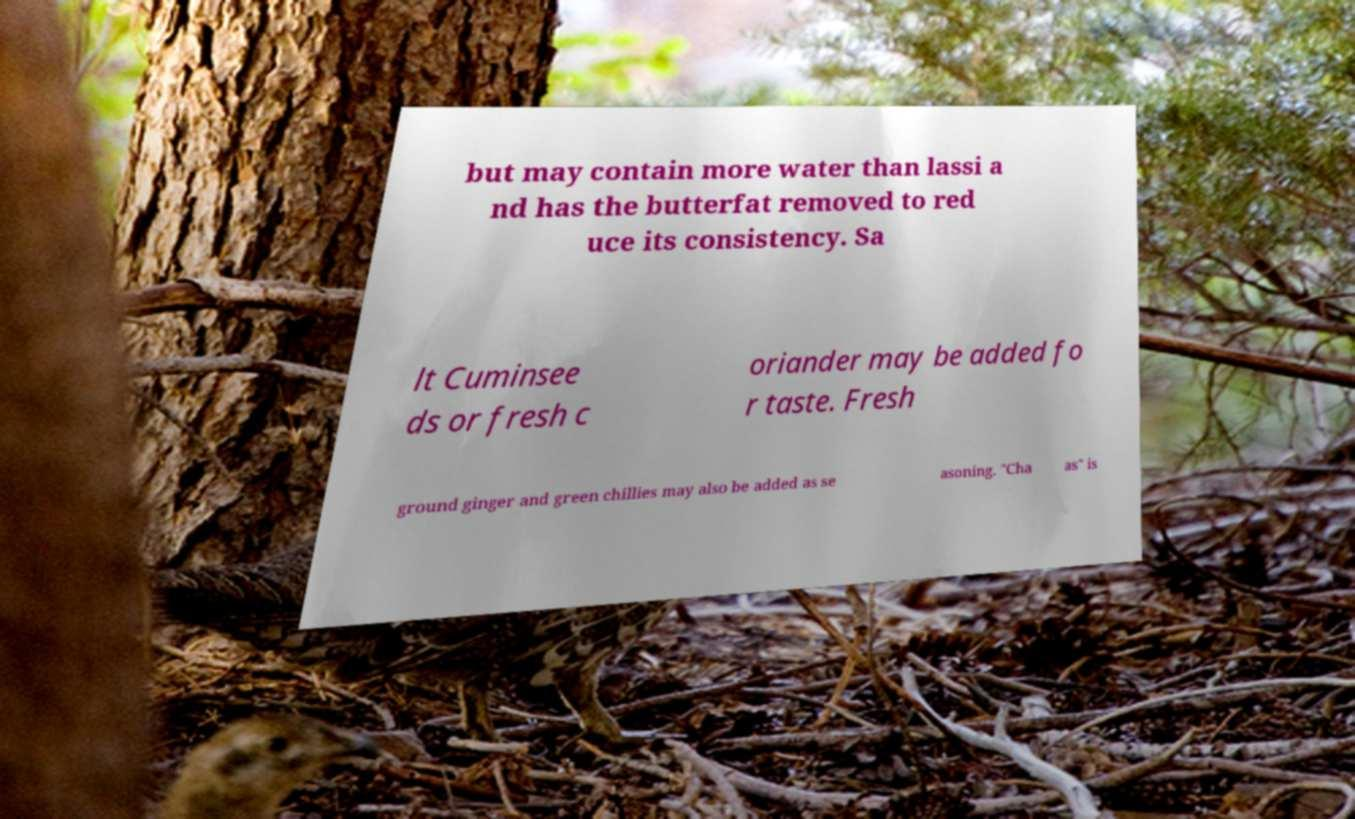What messages or text are displayed in this image? I need them in a readable, typed format. but may contain more water than lassi a nd has the butterfat removed to red uce its consistency. Sa lt Cuminsee ds or fresh c oriander may be added fo r taste. Fresh ground ginger and green chillies may also be added as se asoning. "Cha as" is 